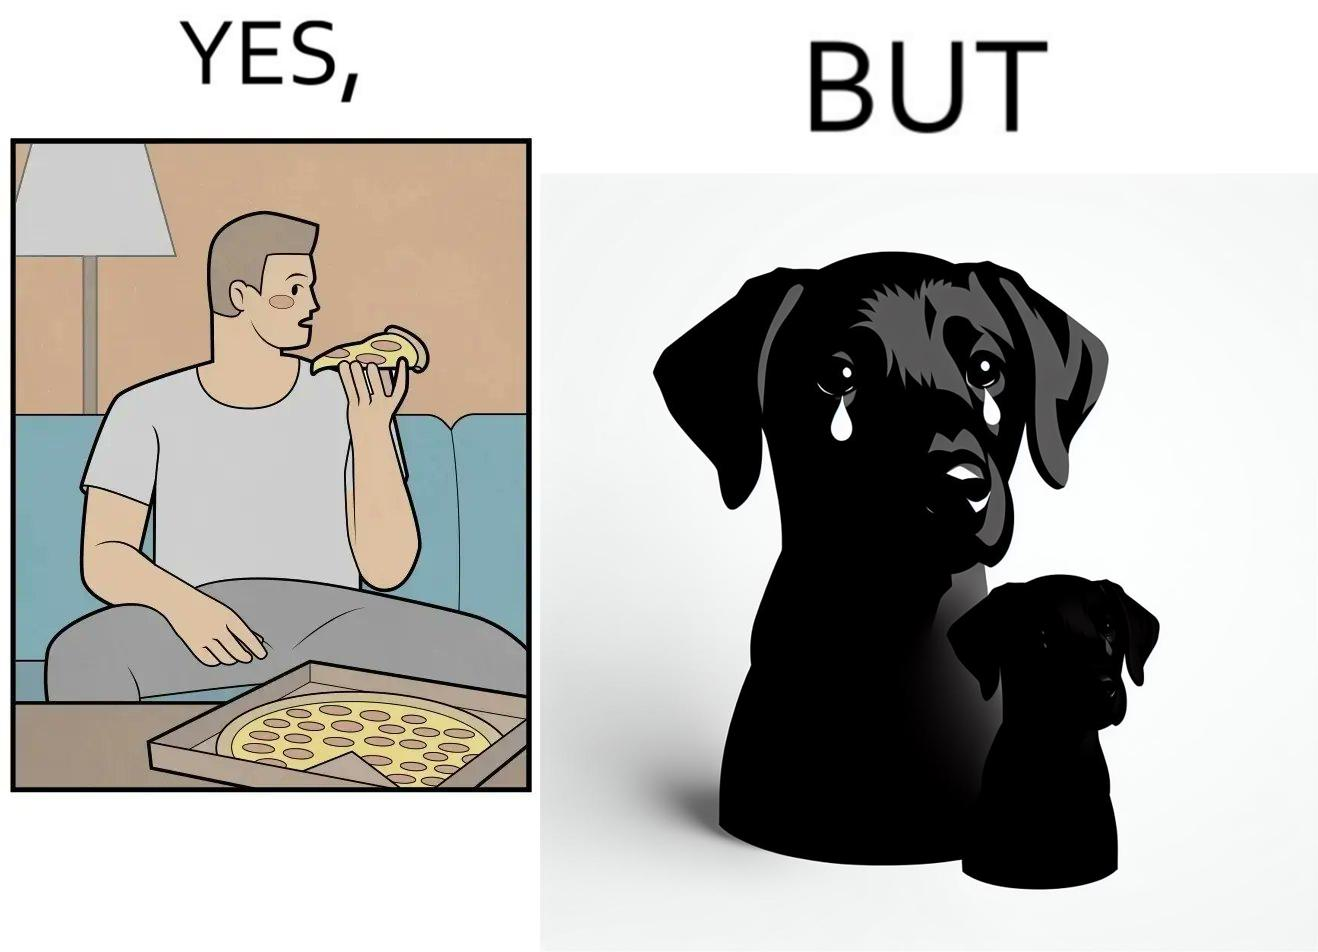What is shown in the left half versus the right half of this image? In the left part of the image: It is a man eating a pizza In the right part of the image: It is a pet dog with teary eyes 